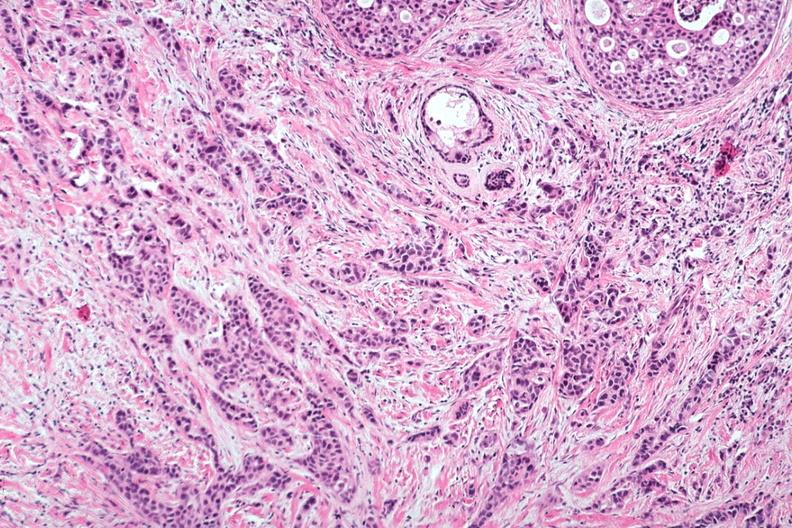does this image show excellent invasive tumor with marked desmoplastic reaction?
Answer the question using a single word or phrase. Yes 